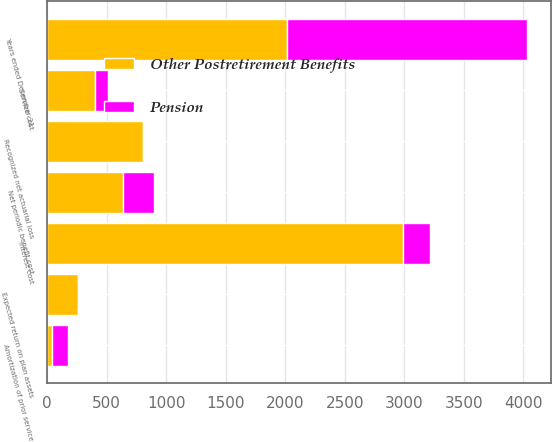Convert chart. <chart><loc_0><loc_0><loc_500><loc_500><stacked_bar_chart><ecel><fcel>Years ended December 31<fcel>Service cost<fcel>Interest cost<fcel>Expected return on plan assets<fcel>Amortization of prior service<fcel>Recognized net actuarial loss<fcel>Net periodic benefit cost<nl><fcel>Other Postretirement Benefits<fcel>2017<fcel>402<fcel>2991<fcel>262<fcel>39<fcel>804<fcel>639<nl><fcel>Pension<fcel>2017<fcel>106<fcel>229<fcel>7<fcel>137<fcel>10<fcel>262<nl></chart> 